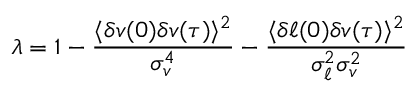Convert formula to latex. <formula><loc_0><loc_0><loc_500><loc_500>\lambda = 1 - \frac { \langle \delta v ( 0 ) \delta v ( \tau ) \rangle ^ { 2 } } { \sigma _ { v } ^ { 4 } } - \frac { \langle \delta \ell ( 0 ) \delta v ( \tau ) \rangle ^ { 2 } } { \sigma _ { \ell } ^ { 2 } \sigma _ { v } ^ { 2 } }</formula> 